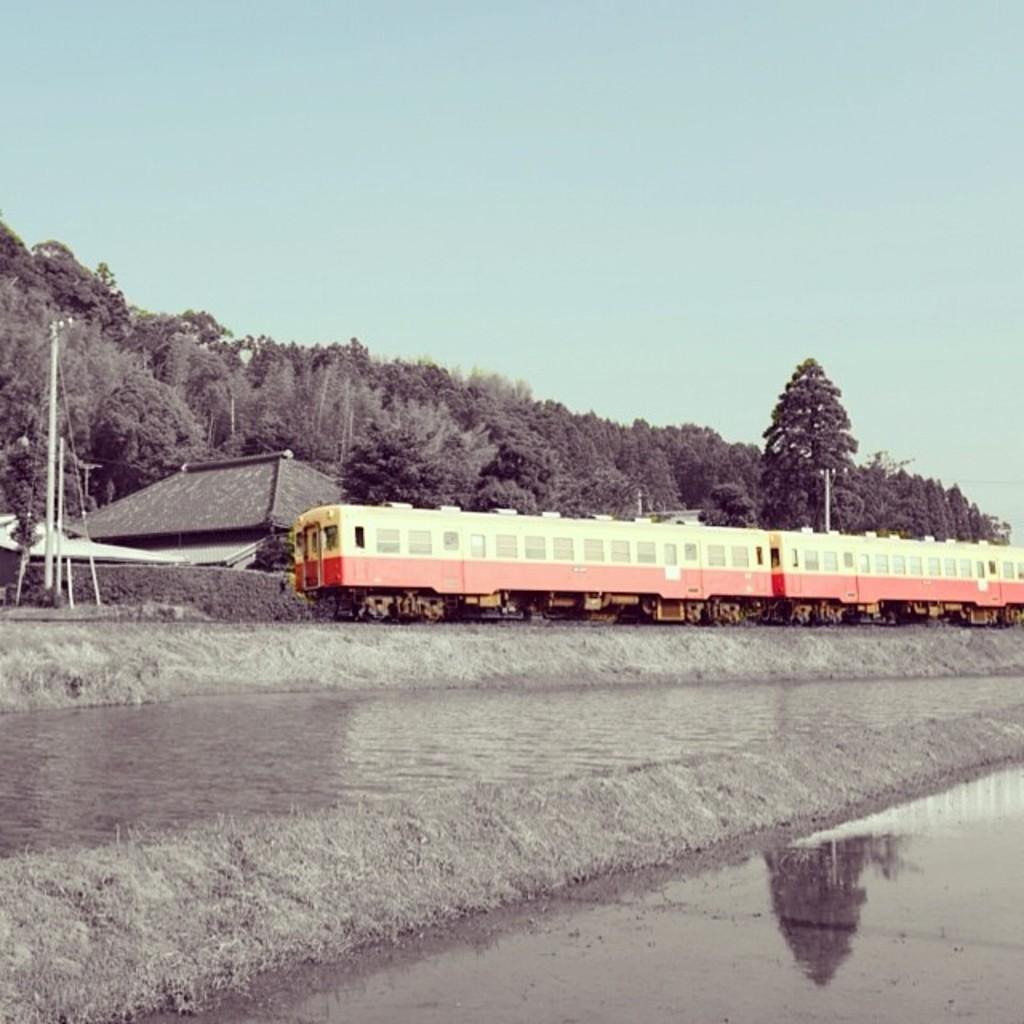In one or two sentences, can you explain what this image depicts? In this image we can see a train. Behind the train we can see a house and a group of trees. In the foreground we can see the fields. On the left side, we can see a pole. At the top we can see the sky. 